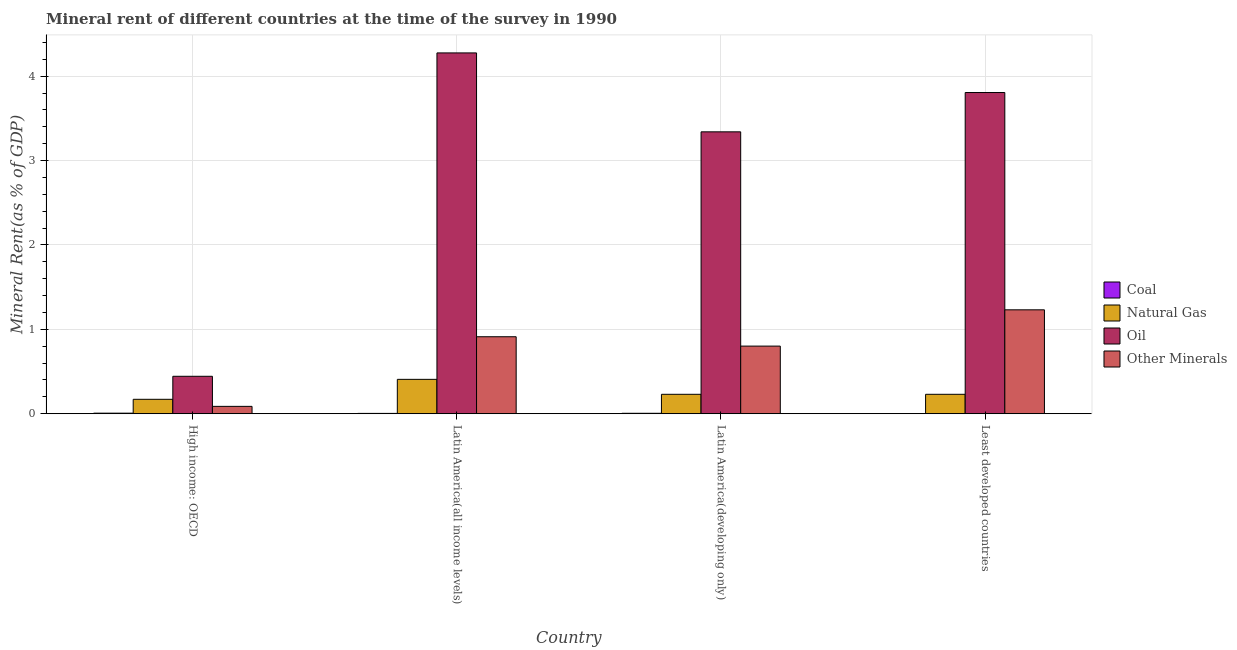Are the number of bars per tick equal to the number of legend labels?
Your answer should be compact. Yes. Are the number of bars on each tick of the X-axis equal?
Provide a short and direct response. Yes. How many bars are there on the 2nd tick from the left?
Offer a very short reply. 4. What is the label of the 3rd group of bars from the left?
Ensure brevity in your answer.  Latin America(developing only). What is the natural gas rent in High income: OECD?
Offer a terse response. 0.17. Across all countries, what is the maximum natural gas rent?
Ensure brevity in your answer.  0.41. Across all countries, what is the minimum oil rent?
Keep it short and to the point. 0.44. In which country was the natural gas rent maximum?
Provide a succinct answer. Latin America(all income levels). In which country was the natural gas rent minimum?
Offer a very short reply. High income: OECD. What is the total  rent of other minerals in the graph?
Ensure brevity in your answer.  3.03. What is the difference between the  rent of other minerals in High income: OECD and that in Latin America(developing only)?
Provide a succinct answer. -0.71. What is the difference between the coal rent in Latin America(all income levels) and the natural gas rent in Latin America(developing only)?
Provide a succinct answer. -0.23. What is the average oil rent per country?
Provide a short and direct response. 2.97. What is the difference between the natural gas rent and coal rent in Least developed countries?
Make the answer very short. 0.23. In how many countries, is the oil rent greater than 1 %?
Offer a very short reply. 3. What is the ratio of the natural gas rent in High income: OECD to that in Latin America(all income levels)?
Give a very brief answer. 0.42. What is the difference between the highest and the second highest coal rent?
Provide a succinct answer. 0. What is the difference between the highest and the lowest coal rent?
Make the answer very short. 0.01. In how many countries, is the oil rent greater than the average oil rent taken over all countries?
Provide a short and direct response. 3. Is it the case that in every country, the sum of the  rent of other minerals and oil rent is greater than the sum of coal rent and natural gas rent?
Ensure brevity in your answer.  Yes. What does the 2nd bar from the left in High income: OECD represents?
Offer a terse response. Natural Gas. What does the 4th bar from the right in Latin America(developing only) represents?
Offer a very short reply. Coal. How many bars are there?
Keep it short and to the point. 16. Are all the bars in the graph horizontal?
Your response must be concise. No. What is the difference between two consecutive major ticks on the Y-axis?
Make the answer very short. 1. Are the values on the major ticks of Y-axis written in scientific E-notation?
Provide a short and direct response. No. Does the graph contain grids?
Keep it short and to the point. Yes. How many legend labels are there?
Offer a very short reply. 4. What is the title of the graph?
Offer a terse response. Mineral rent of different countries at the time of the survey in 1990. What is the label or title of the X-axis?
Offer a very short reply. Country. What is the label or title of the Y-axis?
Keep it short and to the point. Mineral Rent(as % of GDP). What is the Mineral Rent(as % of GDP) of Coal in High income: OECD?
Your response must be concise. 0.01. What is the Mineral Rent(as % of GDP) of Natural Gas in High income: OECD?
Make the answer very short. 0.17. What is the Mineral Rent(as % of GDP) in Oil in High income: OECD?
Offer a terse response. 0.44. What is the Mineral Rent(as % of GDP) in Other Minerals in High income: OECD?
Your answer should be compact. 0.09. What is the Mineral Rent(as % of GDP) of Coal in Latin America(all income levels)?
Provide a short and direct response. 0. What is the Mineral Rent(as % of GDP) in Natural Gas in Latin America(all income levels)?
Your answer should be compact. 0.41. What is the Mineral Rent(as % of GDP) in Oil in Latin America(all income levels)?
Keep it short and to the point. 4.28. What is the Mineral Rent(as % of GDP) of Other Minerals in Latin America(all income levels)?
Ensure brevity in your answer.  0.91. What is the Mineral Rent(as % of GDP) in Coal in Latin America(developing only)?
Provide a short and direct response. 0.01. What is the Mineral Rent(as % of GDP) in Natural Gas in Latin America(developing only)?
Offer a very short reply. 0.23. What is the Mineral Rent(as % of GDP) in Oil in Latin America(developing only)?
Provide a short and direct response. 3.34. What is the Mineral Rent(as % of GDP) in Other Minerals in Latin America(developing only)?
Ensure brevity in your answer.  0.8. What is the Mineral Rent(as % of GDP) in Coal in Least developed countries?
Your answer should be very brief. 0. What is the Mineral Rent(as % of GDP) in Natural Gas in Least developed countries?
Keep it short and to the point. 0.23. What is the Mineral Rent(as % of GDP) in Oil in Least developed countries?
Provide a succinct answer. 3.81. What is the Mineral Rent(as % of GDP) of Other Minerals in Least developed countries?
Provide a succinct answer. 1.23. Across all countries, what is the maximum Mineral Rent(as % of GDP) of Coal?
Offer a terse response. 0.01. Across all countries, what is the maximum Mineral Rent(as % of GDP) of Natural Gas?
Offer a very short reply. 0.41. Across all countries, what is the maximum Mineral Rent(as % of GDP) in Oil?
Offer a very short reply. 4.28. Across all countries, what is the maximum Mineral Rent(as % of GDP) of Other Minerals?
Provide a short and direct response. 1.23. Across all countries, what is the minimum Mineral Rent(as % of GDP) in Coal?
Your response must be concise. 0. Across all countries, what is the minimum Mineral Rent(as % of GDP) of Natural Gas?
Ensure brevity in your answer.  0.17. Across all countries, what is the minimum Mineral Rent(as % of GDP) in Oil?
Offer a terse response. 0.44. Across all countries, what is the minimum Mineral Rent(as % of GDP) in Other Minerals?
Ensure brevity in your answer.  0.09. What is the total Mineral Rent(as % of GDP) of Coal in the graph?
Ensure brevity in your answer.  0.02. What is the total Mineral Rent(as % of GDP) of Natural Gas in the graph?
Your response must be concise. 1.04. What is the total Mineral Rent(as % of GDP) in Oil in the graph?
Give a very brief answer. 11.87. What is the total Mineral Rent(as % of GDP) in Other Minerals in the graph?
Provide a succinct answer. 3.03. What is the difference between the Mineral Rent(as % of GDP) in Coal in High income: OECD and that in Latin America(all income levels)?
Keep it short and to the point. 0. What is the difference between the Mineral Rent(as % of GDP) in Natural Gas in High income: OECD and that in Latin America(all income levels)?
Ensure brevity in your answer.  -0.24. What is the difference between the Mineral Rent(as % of GDP) of Oil in High income: OECD and that in Latin America(all income levels)?
Your answer should be compact. -3.83. What is the difference between the Mineral Rent(as % of GDP) of Other Minerals in High income: OECD and that in Latin America(all income levels)?
Your answer should be compact. -0.82. What is the difference between the Mineral Rent(as % of GDP) in Coal in High income: OECD and that in Latin America(developing only)?
Give a very brief answer. 0. What is the difference between the Mineral Rent(as % of GDP) in Natural Gas in High income: OECD and that in Latin America(developing only)?
Keep it short and to the point. -0.06. What is the difference between the Mineral Rent(as % of GDP) of Oil in High income: OECD and that in Latin America(developing only)?
Your response must be concise. -2.9. What is the difference between the Mineral Rent(as % of GDP) of Other Minerals in High income: OECD and that in Latin America(developing only)?
Offer a very short reply. -0.71. What is the difference between the Mineral Rent(as % of GDP) of Coal in High income: OECD and that in Least developed countries?
Provide a succinct answer. 0.01. What is the difference between the Mineral Rent(as % of GDP) in Natural Gas in High income: OECD and that in Least developed countries?
Offer a very short reply. -0.06. What is the difference between the Mineral Rent(as % of GDP) of Oil in High income: OECD and that in Least developed countries?
Keep it short and to the point. -3.36. What is the difference between the Mineral Rent(as % of GDP) of Other Minerals in High income: OECD and that in Least developed countries?
Your answer should be compact. -1.14. What is the difference between the Mineral Rent(as % of GDP) of Coal in Latin America(all income levels) and that in Latin America(developing only)?
Provide a short and direct response. -0. What is the difference between the Mineral Rent(as % of GDP) in Natural Gas in Latin America(all income levels) and that in Latin America(developing only)?
Your response must be concise. 0.18. What is the difference between the Mineral Rent(as % of GDP) of Oil in Latin America(all income levels) and that in Latin America(developing only)?
Provide a short and direct response. 0.94. What is the difference between the Mineral Rent(as % of GDP) of Other Minerals in Latin America(all income levels) and that in Latin America(developing only)?
Make the answer very short. 0.11. What is the difference between the Mineral Rent(as % of GDP) in Coal in Latin America(all income levels) and that in Least developed countries?
Your answer should be compact. 0. What is the difference between the Mineral Rent(as % of GDP) in Natural Gas in Latin America(all income levels) and that in Least developed countries?
Give a very brief answer. 0.18. What is the difference between the Mineral Rent(as % of GDP) of Oil in Latin America(all income levels) and that in Least developed countries?
Provide a short and direct response. 0.47. What is the difference between the Mineral Rent(as % of GDP) of Other Minerals in Latin America(all income levels) and that in Least developed countries?
Make the answer very short. -0.32. What is the difference between the Mineral Rent(as % of GDP) of Coal in Latin America(developing only) and that in Least developed countries?
Give a very brief answer. 0. What is the difference between the Mineral Rent(as % of GDP) of Natural Gas in Latin America(developing only) and that in Least developed countries?
Your answer should be compact. -0. What is the difference between the Mineral Rent(as % of GDP) of Oil in Latin America(developing only) and that in Least developed countries?
Provide a short and direct response. -0.47. What is the difference between the Mineral Rent(as % of GDP) of Other Minerals in Latin America(developing only) and that in Least developed countries?
Offer a terse response. -0.43. What is the difference between the Mineral Rent(as % of GDP) in Coal in High income: OECD and the Mineral Rent(as % of GDP) in Natural Gas in Latin America(all income levels)?
Offer a terse response. -0.4. What is the difference between the Mineral Rent(as % of GDP) of Coal in High income: OECD and the Mineral Rent(as % of GDP) of Oil in Latin America(all income levels)?
Keep it short and to the point. -4.27. What is the difference between the Mineral Rent(as % of GDP) of Coal in High income: OECD and the Mineral Rent(as % of GDP) of Other Minerals in Latin America(all income levels)?
Provide a short and direct response. -0.91. What is the difference between the Mineral Rent(as % of GDP) of Natural Gas in High income: OECD and the Mineral Rent(as % of GDP) of Oil in Latin America(all income levels)?
Your answer should be very brief. -4.1. What is the difference between the Mineral Rent(as % of GDP) of Natural Gas in High income: OECD and the Mineral Rent(as % of GDP) of Other Minerals in Latin America(all income levels)?
Make the answer very short. -0.74. What is the difference between the Mineral Rent(as % of GDP) of Oil in High income: OECD and the Mineral Rent(as % of GDP) of Other Minerals in Latin America(all income levels)?
Provide a succinct answer. -0.47. What is the difference between the Mineral Rent(as % of GDP) of Coal in High income: OECD and the Mineral Rent(as % of GDP) of Natural Gas in Latin America(developing only)?
Keep it short and to the point. -0.22. What is the difference between the Mineral Rent(as % of GDP) of Coal in High income: OECD and the Mineral Rent(as % of GDP) of Oil in Latin America(developing only)?
Your answer should be very brief. -3.33. What is the difference between the Mineral Rent(as % of GDP) in Coal in High income: OECD and the Mineral Rent(as % of GDP) in Other Minerals in Latin America(developing only)?
Your response must be concise. -0.79. What is the difference between the Mineral Rent(as % of GDP) in Natural Gas in High income: OECD and the Mineral Rent(as % of GDP) in Oil in Latin America(developing only)?
Your answer should be compact. -3.17. What is the difference between the Mineral Rent(as % of GDP) of Natural Gas in High income: OECD and the Mineral Rent(as % of GDP) of Other Minerals in Latin America(developing only)?
Your answer should be compact. -0.63. What is the difference between the Mineral Rent(as % of GDP) of Oil in High income: OECD and the Mineral Rent(as % of GDP) of Other Minerals in Latin America(developing only)?
Provide a short and direct response. -0.36. What is the difference between the Mineral Rent(as % of GDP) in Coal in High income: OECD and the Mineral Rent(as % of GDP) in Natural Gas in Least developed countries?
Offer a very short reply. -0.22. What is the difference between the Mineral Rent(as % of GDP) in Coal in High income: OECD and the Mineral Rent(as % of GDP) in Oil in Least developed countries?
Give a very brief answer. -3.8. What is the difference between the Mineral Rent(as % of GDP) of Coal in High income: OECD and the Mineral Rent(as % of GDP) of Other Minerals in Least developed countries?
Ensure brevity in your answer.  -1.22. What is the difference between the Mineral Rent(as % of GDP) of Natural Gas in High income: OECD and the Mineral Rent(as % of GDP) of Oil in Least developed countries?
Provide a short and direct response. -3.63. What is the difference between the Mineral Rent(as % of GDP) in Natural Gas in High income: OECD and the Mineral Rent(as % of GDP) in Other Minerals in Least developed countries?
Your answer should be compact. -1.06. What is the difference between the Mineral Rent(as % of GDP) of Oil in High income: OECD and the Mineral Rent(as % of GDP) of Other Minerals in Least developed countries?
Your answer should be very brief. -0.79. What is the difference between the Mineral Rent(as % of GDP) of Coal in Latin America(all income levels) and the Mineral Rent(as % of GDP) of Natural Gas in Latin America(developing only)?
Provide a succinct answer. -0.23. What is the difference between the Mineral Rent(as % of GDP) in Coal in Latin America(all income levels) and the Mineral Rent(as % of GDP) in Oil in Latin America(developing only)?
Offer a very short reply. -3.34. What is the difference between the Mineral Rent(as % of GDP) in Coal in Latin America(all income levels) and the Mineral Rent(as % of GDP) in Other Minerals in Latin America(developing only)?
Provide a succinct answer. -0.8. What is the difference between the Mineral Rent(as % of GDP) in Natural Gas in Latin America(all income levels) and the Mineral Rent(as % of GDP) in Oil in Latin America(developing only)?
Your answer should be compact. -2.93. What is the difference between the Mineral Rent(as % of GDP) of Natural Gas in Latin America(all income levels) and the Mineral Rent(as % of GDP) of Other Minerals in Latin America(developing only)?
Your answer should be compact. -0.39. What is the difference between the Mineral Rent(as % of GDP) of Oil in Latin America(all income levels) and the Mineral Rent(as % of GDP) of Other Minerals in Latin America(developing only)?
Ensure brevity in your answer.  3.47. What is the difference between the Mineral Rent(as % of GDP) in Coal in Latin America(all income levels) and the Mineral Rent(as % of GDP) in Natural Gas in Least developed countries?
Make the answer very short. -0.23. What is the difference between the Mineral Rent(as % of GDP) in Coal in Latin America(all income levels) and the Mineral Rent(as % of GDP) in Oil in Least developed countries?
Your answer should be very brief. -3.8. What is the difference between the Mineral Rent(as % of GDP) of Coal in Latin America(all income levels) and the Mineral Rent(as % of GDP) of Other Minerals in Least developed countries?
Your answer should be compact. -1.23. What is the difference between the Mineral Rent(as % of GDP) of Natural Gas in Latin America(all income levels) and the Mineral Rent(as % of GDP) of Oil in Least developed countries?
Your answer should be compact. -3.4. What is the difference between the Mineral Rent(as % of GDP) in Natural Gas in Latin America(all income levels) and the Mineral Rent(as % of GDP) in Other Minerals in Least developed countries?
Keep it short and to the point. -0.82. What is the difference between the Mineral Rent(as % of GDP) of Oil in Latin America(all income levels) and the Mineral Rent(as % of GDP) of Other Minerals in Least developed countries?
Make the answer very short. 3.04. What is the difference between the Mineral Rent(as % of GDP) in Coal in Latin America(developing only) and the Mineral Rent(as % of GDP) in Natural Gas in Least developed countries?
Give a very brief answer. -0.22. What is the difference between the Mineral Rent(as % of GDP) of Coal in Latin America(developing only) and the Mineral Rent(as % of GDP) of Oil in Least developed countries?
Give a very brief answer. -3.8. What is the difference between the Mineral Rent(as % of GDP) of Coal in Latin America(developing only) and the Mineral Rent(as % of GDP) of Other Minerals in Least developed countries?
Offer a terse response. -1.23. What is the difference between the Mineral Rent(as % of GDP) of Natural Gas in Latin America(developing only) and the Mineral Rent(as % of GDP) of Oil in Least developed countries?
Your answer should be very brief. -3.58. What is the difference between the Mineral Rent(as % of GDP) in Natural Gas in Latin America(developing only) and the Mineral Rent(as % of GDP) in Other Minerals in Least developed countries?
Ensure brevity in your answer.  -1. What is the difference between the Mineral Rent(as % of GDP) in Oil in Latin America(developing only) and the Mineral Rent(as % of GDP) in Other Minerals in Least developed countries?
Your answer should be compact. 2.11. What is the average Mineral Rent(as % of GDP) in Coal per country?
Your answer should be very brief. 0. What is the average Mineral Rent(as % of GDP) in Natural Gas per country?
Provide a short and direct response. 0.26. What is the average Mineral Rent(as % of GDP) of Oil per country?
Provide a succinct answer. 2.97. What is the average Mineral Rent(as % of GDP) of Other Minerals per country?
Provide a short and direct response. 0.76. What is the difference between the Mineral Rent(as % of GDP) in Coal and Mineral Rent(as % of GDP) in Natural Gas in High income: OECD?
Keep it short and to the point. -0.16. What is the difference between the Mineral Rent(as % of GDP) of Coal and Mineral Rent(as % of GDP) of Oil in High income: OECD?
Provide a short and direct response. -0.44. What is the difference between the Mineral Rent(as % of GDP) of Coal and Mineral Rent(as % of GDP) of Other Minerals in High income: OECD?
Ensure brevity in your answer.  -0.08. What is the difference between the Mineral Rent(as % of GDP) of Natural Gas and Mineral Rent(as % of GDP) of Oil in High income: OECD?
Your answer should be compact. -0.27. What is the difference between the Mineral Rent(as % of GDP) of Natural Gas and Mineral Rent(as % of GDP) of Other Minerals in High income: OECD?
Provide a short and direct response. 0.08. What is the difference between the Mineral Rent(as % of GDP) in Oil and Mineral Rent(as % of GDP) in Other Minerals in High income: OECD?
Your answer should be compact. 0.36. What is the difference between the Mineral Rent(as % of GDP) of Coal and Mineral Rent(as % of GDP) of Natural Gas in Latin America(all income levels)?
Ensure brevity in your answer.  -0.4. What is the difference between the Mineral Rent(as % of GDP) in Coal and Mineral Rent(as % of GDP) in Oil in Latin America(all income levels)?
Provide a short and direct response. -4.27. What is the difference between the Mineral Rent(as % of GDP) in Coal and Mineral Rent(as % of GDP) in Other Minerals in Latin America(all income levels)?
Give a very brief answer. -0.91. What is the difference between the Mineral Rent(as % of GDP) in Natural Gas and Mineral Rent(as % of GDP) in Oil in Latin America(all income levels)?
Ensure brevity in your answer.  -3.87. What is the difference between the Mineral Rent(as % of GDP) in Natural Gas and Mineral Rent(as % of GDP) in Other Minerals in Latin America(all income levels)?
Keep it short and to the point. -0.5. What is the difference between the Mineral Rent(as % of GDP) of Oil and Mineral Rent(as % of GDP) of Other Minerals in Latin America(all income levels)?
Your answer should be compact. 3.36. What is the difference between the Mineral Rent(as % of GDP) in Coal and Mineral Rent(as % of GDP) in Natural Gas in Latin America(developing only)?
Offer a very short reply. -0.22. What is the difference between the Mineral Rent(as % of GDP) of Coal and Mineral Rent(as % of GDP) of Oil in Latin America(developing only)?
Your response must be concise. -3.33. What is the difference between the Mineral Rent(as % of GDP) of Coal and Mineral Rent(as % of GDP) of Other Minerals in Latin America(developing only)?
Offer a very short reply. -0.8. What is the difference between the Mineral Rent(as % of GDP) of Natural Gas and Mineral Rent(as % of GDP) of Oil in Latin America(developing only)?
Your response must be concise. -3.11. What is the difference between the Mineral Rent(as % of GDP) in Natural Gas and Mineral Rent(as % of GDP) in Other Minerals in Latin America(developing only)?
Give a very brief answer. -0.57. What is the difference between the Mineral Rent(as % of GDP) of Oil and Mineral Rent(as % of GDP) of Other Minerals in Latin America(developing only)?
Keep it short and to the point. 2.54. What is the difference between the Mineral Rent(as % of GDP) of Coal and Mineral Rent(as % of GDP) of Natural Gas in Least developed countries?
Make the answer very short. -0.23. What is the difference between the Mineral Rent(as % of GDP) in Coal and Mineral Rent(as % of GDP) in Oil in Least developed countries?
Your answer should be compact. -3.81. What is the difference between the Mineral Rent(as % of GDP) in Coal and Mineral Rent(as % of GDP) in Other Minerals in Least developed countries?
Ensure brevity in your answer.  -1.23. What is the difference between the Mineral Rent(as % of GDP) in Natural Gas and Mineral Rent(as % of GDP) in Oil in Least developed countries?
Your response must be concise. -3.58. What is the difference between the Mineral Rent(as % of GDP) in Natural Gas and Mineral Rent(as % of GDP) in Other Minerals in Least developed countries?
Keep it short and to the point. -1. What is the difference between the Mineral Rent(as % of GDP) in Oil and Mineral Rent(as % of GDP) in Other Minerals in Least developed countries?
Ensure brevity in your answer.  2.57. What is the ratio of the Mineral Rent(as % of GDP) of Coal in High income: OECD to that in Latin America(all income levels)?
Provide a succinct answer. 1.68. What is the ratio of the Mineral Rent(as % of GDP) in Natural Gas in High income: OECD to that in Latin America(all income levels)?
Provide a short and direct response. 0.42. What is the ratio of the Mineral Rent(as % of GDP) of Oil in High income: OECD to that in Latin America(all income levels)?
Your response must be concise. 0.1. What is the ratio of the Mineral Rent(as % of GDP) in Other Minerals in High income: OECD to that in Latin America(all income levels)?
Keep it short and to the point. 0.1. What is the ratio of the Mineral Rent(as % of GDP) of Coal in High income: OECD to that in Latin America(developing only)?
Provide a short and direct response. 1.29. What is the ratio of the Mineral Rent(as % of GDP) of Natural Gas in High income: OECD to that in Latin America(developing only)?
Offer a very short reply. 0.74. What is the ratio of the Mineral Rent(as % of GDP) of Oil in High income: OECD to that in Latin America(developing only)?
Your answer should be very brief. 0.13. What is the ratio of the Mineral Rent(as % of GDP) of Other Minerals in High income: OECD to that in Latin America(developing only)?
Your response must be concise. 0.11. What is the ratio of the Mineral Rent(as % of GDP) of Coal in High income: OECD to that in Least developed countries?
Your answer should be very brief. 8.42. What is the ratio of the Mineral Rent(as % of GDP) of Natural Gas in High income: OECD to that in Least developed countries?
Make the answer very short. 0.74. What is the ratio of the Mineral Rent(as % of GDP) in Oil in High income: OECD to that in Least developed countries?
Your answer should be compact. 0.12. What is the ratio of the Mineral Rent(as % of GDP) in Other Minerals in High income: OECD to that in Least developed countries?
Your answer should be very brief. 0.07. What is the ratio of the Mineral Rent(as % of GDP) of Coal in Latin America(all income levels) to that in Latin America(developing only)?
Your answer should be very brief. 0.77. What is the ratio of the Mineral Rent(as % of GDP) of Natural Gas in Latin America(all income levels) to that in Latin America(developing only)?
Provide a succinct answer. 1.77. What is the ratio of the Mineral Rent(as % of GDP) in Oil in Latin America(all income levels) to that in Latin America(developing only)?
Ensure brevity in your answer.  1.28. What is the ratio of the Mineral Rent(as % of GDP) in Other Minerals in Latin America(all income levels) to that in Latin America(developing only)?
Provide a short and direct response. 1.14. What is the ratio of the Mineral Rent(as % of GDP) of Coal in Latin America(all income levels) to that in Least developed countries?
Your response must be concise. 5. What is the ratio of the Mineral Rent(as % of GDP) in Natural Gas in Latin America(all income levels) to that in Least developed countries?
Offer a very short reply. 1.77. What is the ratio of the Mineral Rent(as % of GDP) of Oil in Latin America(all income levels) to that in Least developed countries?
Keep it short and to the point. 1.12. What is the ratio of the Mineral Rent(as % of GDP) in Other Minerals in Latin America(all income levels) to that in Least developed countries?
Make the answer very short. 0.74. What is the ratio of the Mineral Rent(as % of GDP) of Coal in Latin America(developing only) to that in Least developed countries?
Offer a terse response. 6.53. What is the ratio of the Mineral Rent(as % of GDP) of Oil in Latin America(developing only) to that in Least developed countries?
Provide a succinct answer. 0.88. What is the ratio of the Mineral Rent(as % of GDP) in Other Minerals in Latin America(developing only) to that in Least developed countries?
Offer a very short reply. 0.65. What is the difference between the highest and the second highest Mineral Rent(as % of GDP) of Coal?
Make the answer very short. 0. What is the difference between the highest and the second highest Mineral Rent(as % of GDP) of Natural Gas?
Make the answer very short. 0.18. What is the difference between the highest and the second highest Mineral Rent(as % of GDP) of Oil?
Make the answer very short. 0.47. What is the difference between the highest and the second highest Mineral Rent(as % of GDP) in Other Minerals?
Make the answer very short. 0.32. What is the difference between the highest and the lowest Mineral Rent(as % of GDP) in Coal?
Provide a succinct answer. 0.01. What is the difference between the highest and the lowest Mineral Rent(as % of GDP) of Natural Gas?
Give a very brief answer. 0.24. What is the difference between the highest and the lowest Mineral Rent(as % of GDP) of Oil?
Your answer should be very brief. 3.83. What is the difference between the highest and the lowest Mineral Rent(as % of GDP) of Other Minerals?
Give a very brief answer. 1.14. 